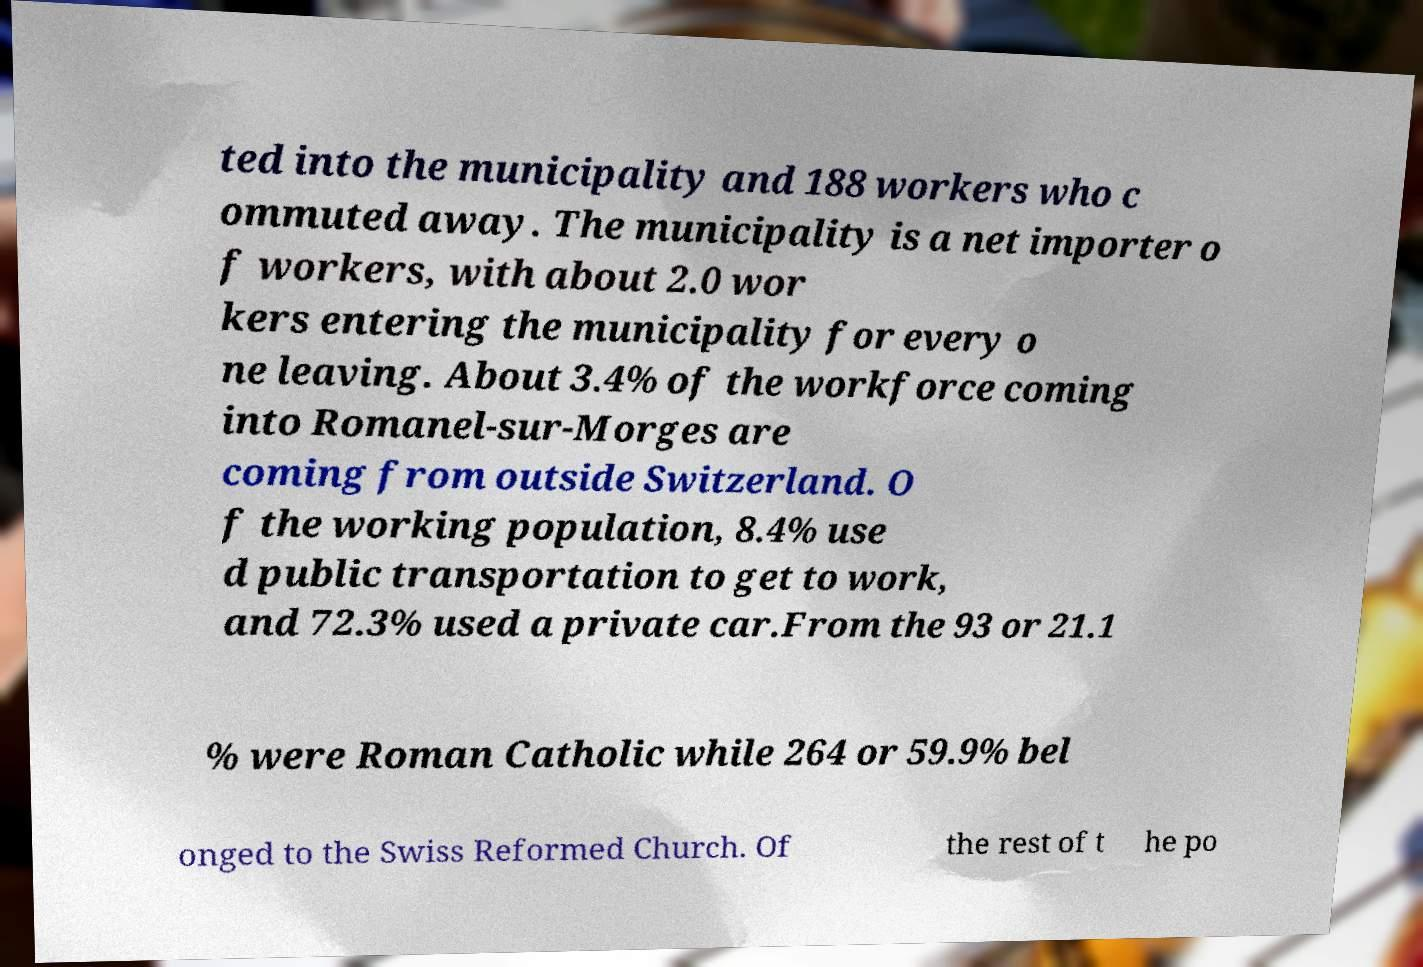Please read and relay the text visible in this image. What does it say? ted into the municipality and 188 workers who c ommuted away. The municipality is a net importer o f workers, with about 2.0 wor kers entering the municipality for every o ne leaving. About 3.4% of the workforce coming into Romanel-sur-Morges are coming from outside Switzerland. O f the working population, 8.4% use d public transportation to get to work, and 72.3% used a private car.From the 93 or 21.1 % were Roman Catholic while 264 or 59.9% bel onged to the Swiss Reformed Church. Of the rest of t he po 